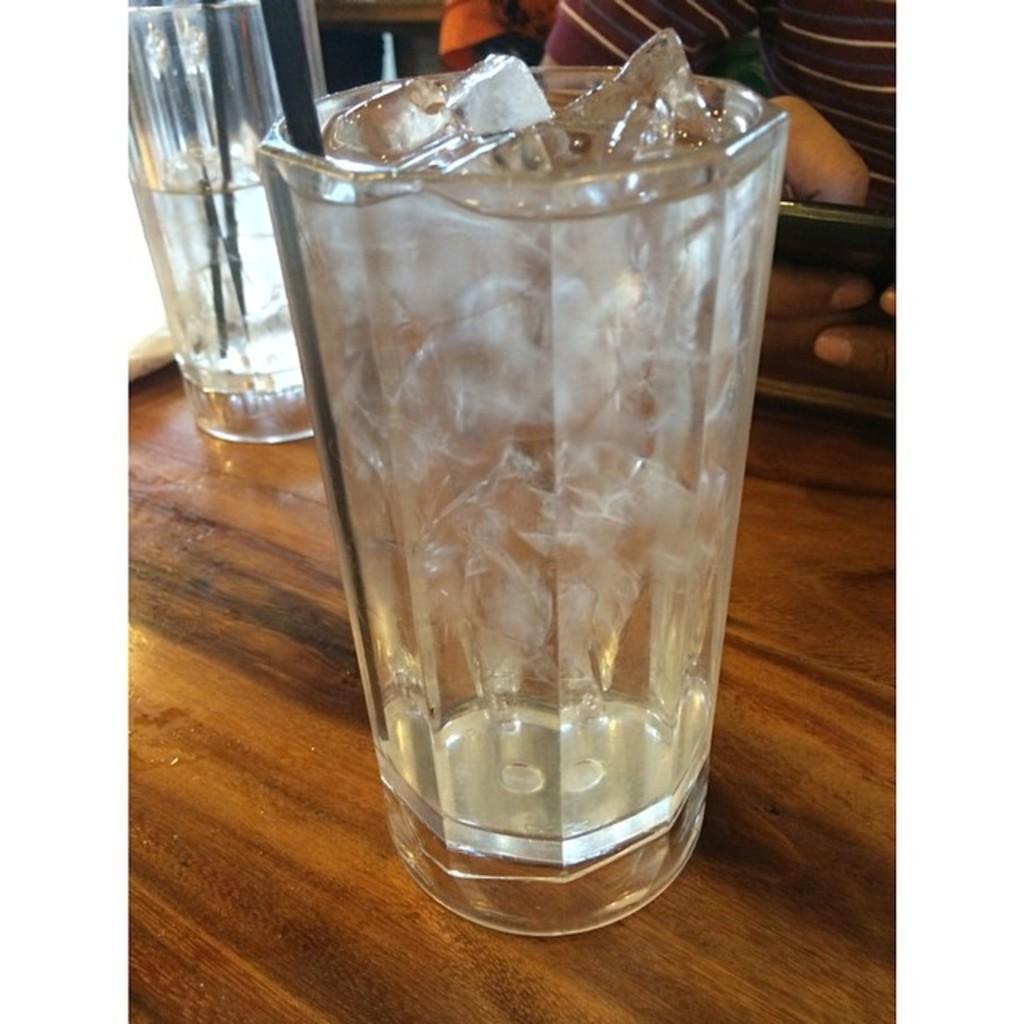Could you give a brief overview of what you see in this image? There are two glasses filled with ice cubes and kept on a wooden surface as we can see in the middle of this image. There is one person holding a mobile as we can see at the top left side of this image. 